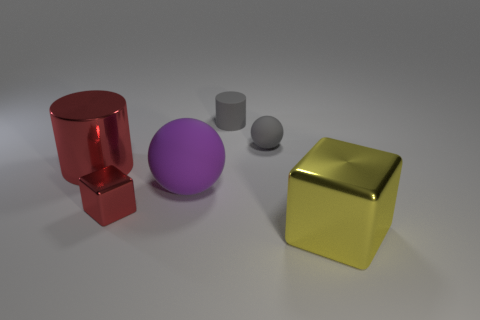Is the color of the ball that is to the left of the small rubber sphere the same as the small rubber ball?
Offer a terse response. No. What number of objects are yellow things or large red objects?
Make the answer very short. 2. What color is the block to the left of the large yellow shiny object?
Offer a very short reply. Red. Are there fewer rubber cylinders in front of the large rubber sphere than large green metal cylinders?
Ensure brevity in your answer.  No. What is the size of the metallic block that is the same color as the large cylinder?
Your answer should be very brief. Small. Is there anything else that is the same size as the gray matte sphere?
Your answer should be very brief. Yes. Do the large purple thing and the tiny red block have the same material?
Give a very brief answer. No. What number of things are things left of the gray cylinder or small matte objects behind the gray rubber sphere?
Offer a terse response. 4. Is there a red cylinder that has the same size as the gray rubber sphere?
Provide a succinct answer. No. The other thing that is the same shape as the big red metallic object is what color?
Ensure brevity in your answer.  Gray. 